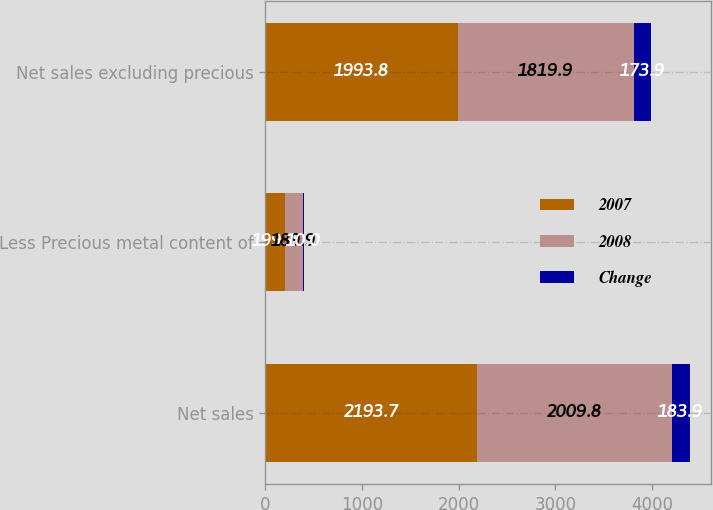<chart> <loc_0><loc_0><loc_500><loc_500><stacked_bar_chart><ecel><fcel>Net sales<fcel>Less Precious metal content of<fcel>Net sales excluding precious<nl><fcel>2007<fcel>2193.7<fcel>199.9<fcel>1993.8<nl><fcel>2008<fcel>2009.8<fcel>189.9<fcel>1819.9<nl><fcel>Change<fcel>183.9<fcel>10<fcel>173.9<nl></chart> 